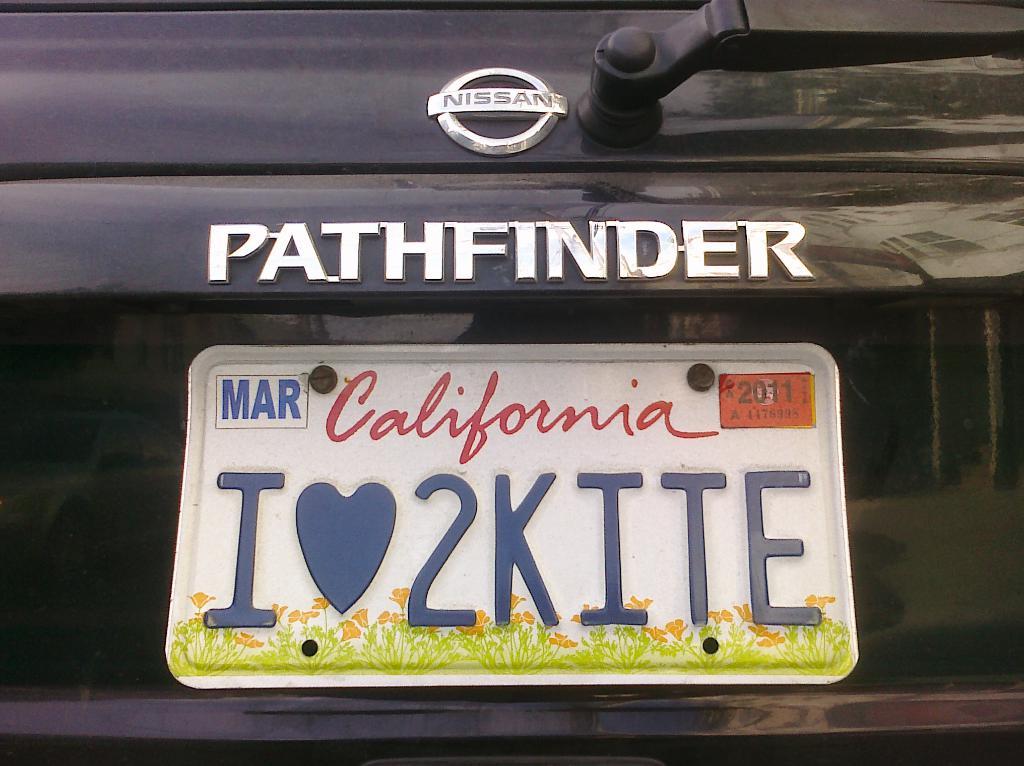What type of nissan is this?
Make the answer very short. Pathfinder. Does the license plate say i love to kite?
Make the answer very short. Yes. 